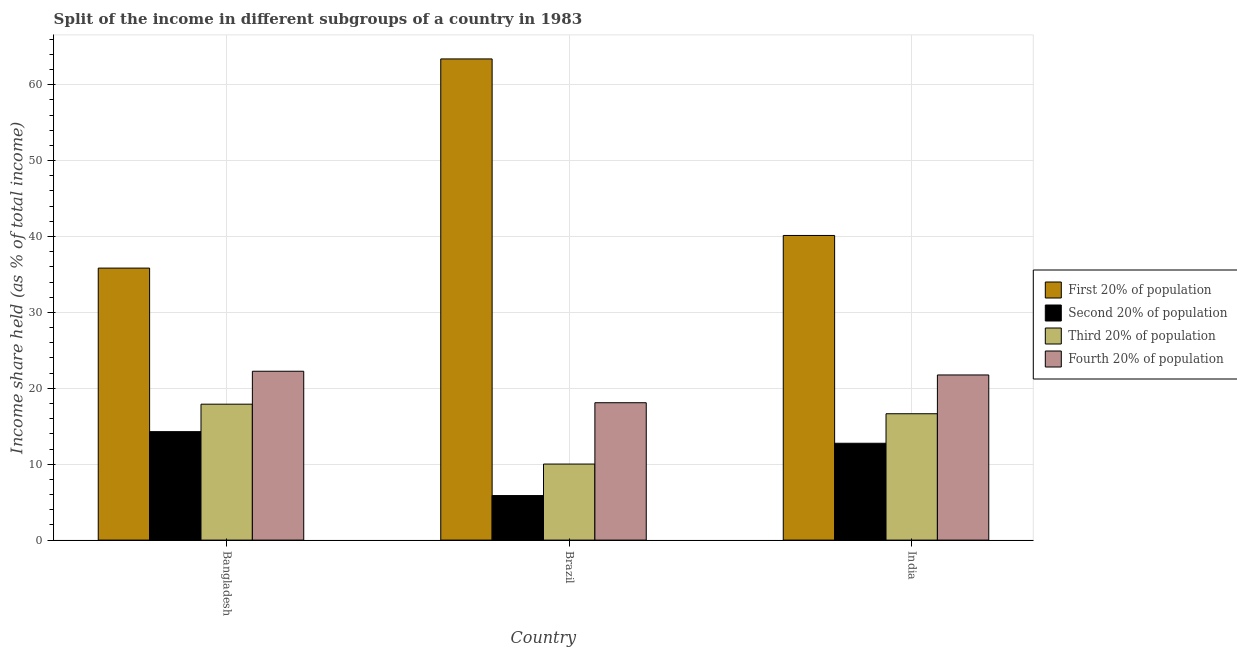How many groups of bars are there?
Make the answer very short. 3. What is the label of the 1st group of bars from the left?
Keep it short and to the point. Bangladesh. In how many cases, is the number of bars for a given country not equal to the number of legend labels?
Provide a short and direct response. 0. What is the share of the income held by first 20% of the population in India?
Offer a very short reply. 40.14. Across all countries, what is the maximum share of the income held by third 20% of the population?
Offer a very short reply. 17.91. Across all countries, what is the minimum share of the income held by second 20% of the population?
Your answer should be very brief. 5.87. In which country was the share of the income held by second 20% of the population maximum?
Your response must be concise. Bangladesh. What is the total share of the income held by first 20% of the population in the graph?
Provide a short and direct response. 139.38. What is the difference between the share of the income held by second 20% of the population in Bangladesh and that in Brazil?
Give a very brief answer. 8.42. What is the difference between the share of the income held by fourth 20% of the population in Brazil and the share of the income held by first 20% of the population in India?
Make the answer very short. -22.04. What is the average share of the income held by third 20% of the population per country?
Your answer should be very brief. 14.86. What is the difference between the share of the income held by third 20% of the population and share of the income held by fourth 20% of the population in Brazil?
Offer a terse response. -8.08. In how many countries, is the share of the income held by second 20% of the population greater than 40 %?
Make the answer very short. 0. What is the ratio of the share of the income held by second 20% of the population in Bangladesh to that in Brazil?
Ensure brevity in your answer.  2.43. What is the difference between the highest and the second highest share of the income held by first 20% of the population?
Provide a succinct answer. 23.26. What is the difference between the highest and the lowest share of the income held by first 20% of the population?
Provide a succinct answer. 27.56. In how many countries, is the share of the income held by third 20% of the population greater than the average share of the income held by third 20% of the population taken over all countries?
Give a very brief answer. 2. Is it the case that in every country, the sum of the share of the income held by fourth 20% of the population and share of the income held by first 20% of the population is greater than the sum of share of the income held by second 20% of the population and share of the income held by third 20% of the population?
Your answer should be compact. Yes. What does the 2nd bar from the left in Brazil represents?
Your answer should be compact. Second 20% of population. What does the 1st bar from the right in India represents?
Keep it short and to the point. Fourth 20% of population. Is it the case that in every country, the sum of the share of the income held by first 20% of the population and share of the income held by second 20% of the population is greater than the share of the income held by third 20% of the population?
Offer a terse response. Yes. How many countries are there in the graph?
Give a very brief answer. 3. What is the difference between two consecutive major ticks on the Y-axis?
Your response must be concise. 10. Does the graph contain grids?
Provide a short and direct response. Yes. How many legend labels are there?
Provide a short and direct response. 4. What is the title of the graph?
Provide a succinct answer. Split of the income in different subgroups of a country in 1983. Does "Argument" appear as one of the legend labels in the graph?
Offer a very short reply. No. What is the label or title of the Y-axis?
Make the answer very short. Income share held (as % of total income). What is the Income share held (as % of total income) in First 20% of population in Bangladesh?
Offer a very short reply. 35.84. What is the Income share held (as % of total income) in Second 20% of population in Bangladesh?
Give a very brief answer. 14.29. What is the Income share held (as % of total income) in Third 20% of population in Bangladesh?
Make the answer very short. 17.91. What is the Income share held (as % of total income) of Fourth 20% of population in Bangladesh?
Your answer should be compact. 22.25. What is the Income share held (as % of total income) of First 20% of population in Brazil?
Make the answer very short. 63.4. What is the Income share held (as % of total income) in Second 20% of population in Brazil?
Give a very brief answer. 5.87. What is the Income share held (as % of total income) of Third 20% of population in Brazil?
Keep it short and to the point. 10.02. What is the Income share held (as % of total income) of First 20% of population in India?
Your answer should be compact. 40.14. What is the Income share held (as % of total income) of Second 20% of population in India?
Give a very brief answer. 12.76. What is the Income share held (as % of total income) of Third 20% of population in India?
Your answer should be compact. 16.65. What is the Income share held (as % of total income) of Fourth 20% of population in India?
Provide a short and direct response. 21.76. Across all countries, what is the maximum Income share held (as % of total income) of First 20% of population?
Your answer should be very brief. 63.4. Across all countries, what is the maximum Income share held (as % of total income) in Second 20% of population?
Your answer should be very brief. 14.29. Across all countries, what is the maximum Income share held (as % of total income) in Third 20% of population?
Make the answer very short. 17.91. Across all countries, what is the maximum Income share held (as % of total income) of Fourth 20% of population?
Provide a succinct answer. 22.25. Across all countries, what is the minimum Income share held (as % of total income) in First 20% of population?
Ensure brevity in your answer.  35.84. Across all countries, what is the minimum Income share held (as % of total income) of Second 20% of population?
Offer a very short reply. 5.87. Across all countries, what is the minimum Income share held (as % of total income) of Third 20% of population?
Keep it short and to the point. 10.02. Across all countries, what is the minimum Income share held (as % of total income) in Fourth 20% of population?
Offer a very short reply. 18.1. What is the total Income share held (as % of total income) of First 20% of population in the graph?
Keep it short and to the point. 139.38. What is the total Income share held (as % of total income) of Second 20% of population in the graph?
Your response must be concise. 32.92. What is the total Income share held (as % of total income) in Third 20% of population in the graph?
Provide a short and direct response. 44.58. What is the total Income share held (as % of total income) of Fourth 20% of population in the graph?
Ensure brevity in your answer.  62.11. What is the difference between the Income share held (as % of total income) of First 20% of population in Bangladesh and that in Brazil?
Offer a terse response. -27.56. What is the difference between the Income share held (as % of total income) in Second 20% of population in Bangladesh and that in Brazil?
Offer a very short reply. 8.42. What is the difference between the Income share held (as % of total income) in Third 20% of population in Bangladesh and that in Brazil?
Your response must be concise. 7.89. What is the difference between the Income share held (as % of total income) of Fourth 20% of population in Bangladesh and that in Brazil?
Offer a very short reply. 4.15. What is the difference between the Income share held (as % of total income) in First 20% of population in Bangladesh and that in India?
Your answer should be compact. -4.3. What is the difference between the Income share held (as % of total income) in Second 20% of population in Bangladesh and that in India?
Keep it short and to the point. 1.53. What is the difference between the Income share held (as % of total income) of Third 20% of population in Bangladesh and that in India?
Offer a very short reply. 1.26. What is the difference between the Income share held (as % of total income) of Fourth 20% of population in Bangladesh and that in India?
Provide a short and direct response. 0.49. What is the difference between the Income share held (as % of total income) in First 20% of population in Brazil and that in India?
Ensure brevity in your answer.  23.26. What is the difference between the Income share held (as % of total income) of Second 20% of population in Brazil and that in India?
Offer a terse response. -6.89. What is the difference between the Income share held (as % of total income) in Third 20% of population in Brazil and that in India?
Offer a terse response. -6.63. What is the difference between the Income share held (as % of total income) in Fourth 20% of population in Brazil and that in India?
Keep it short and to the point. -3.66. What is the difference between the Income share held (as % of total income) of First 20% of population in Bangladesh and the Income share held (as % of total income) of Second 20% of population in Brazil?
Your response must be concise. 29.97. What is the difference between the Income share held (as % of total income) of First 20% of population in Bangladesh and the Income share held (as % of total income) of Third 20% of population in Brazil?
Give a very brief answer. 25.82. What is the difference between the Income share held (as % of total income) in First 20% of population in Bangladesh and the Income share held (as % of total income) in Fourth 20% of population in Brazil?
Your response must be concise. 17.74. What is the difference between the Income share held (as % of total income) in Second 20% of population in Bangladesh and the Income share held (as % of total income) in Third 20% of population in Brazil?
Offer a very short reply. 4.27. What is the difference between the Income share held (as % of total income) of Second 20% of population in Bangladesh and the Income share held (as % of total income) of Fourth 20% of population in Brazil?
Provide a short and direct response. -3.81. What is the difference between the Income share held (as % of total income) of Third 20% of population in Bangladesh and the Income share held (as % of total income) of Fourth 20% of population in Brazil?
Keep it short and to the point. -0.19. What is the difference between the Income share held (as % of total income) of First 20% of population in Bangladesh and the Income share held (as % of total income) of Second 20% of population in India?
Your response must be concise. 23.08. What is the difference between the Income share held (as % of total income) in First 20% of population in Bangladesh and the Income share held (as % of total income) in Third 20% of population in India?
Provide a succinct answer. 19.19. What is the difference between the Income share held (as % of total income) of First 20% of population in Bangladesh and the Income share held (as % of total income) of Fourth 20% of population in India?
Make the answer very short. 14.08. What is the difference between the Income share held (as % of total income) in Second 20% of population in Bangladesh and the Income share held (as % of total income) in Third 20% of population in India?
Your answer should be compact. -2.36. What is the difference between the Income share held (as % of total income) of Second 20% of population in Bangladesh and the Income share held (as % of total income) of Fourth 20% of population in India?
Offer a terse response. -7.47. What is the difference between the Income share held (as % of total income) of Third 20% of population in Bangladesh and the Income share held (as % of total income) of Fourth 20% of population in India?
Your answer should be very brief. -3.85. What is the difference between the Income share held (as % of total income) of First 20% of population in Brazil and the Income share held (as % of total income) of Second 20% of population in India?
Your response must be concise. 50.64. What is the difference between the Income share held (as % of total income) of First 20% of population in Brazil and the Income share held (as % of total income) of Third 20% of population in India?
Your answer should be very brief. 46.75. What is the difference between the Income share held (as % of total income) in First 20% of population in Brazil and the Income share held (as % of total income) in Fourth 20% of population in India?
Give a very brief answer. 41.64. What is the difference between the Income share held (as % of total income) of Second 20% of population in Brazil and the Income share held (as % of total income) of Third 20% of population in India?
Make the answer very short. -10.78. What is the difference between the Income share held (as % of total income) in Second 20% of population in Brazil and the Income share held (as % of total income) in Fourth 20% of population in India?
Your response must be concise. -15.89. What is the difference between the Income share held (as % of total income) of Third 20% of population in Brazil and the Income share held (as % of total income) of Fourth 20% of population in India?
Provide a succinct answer. -11.74. What is the average Income share held (as % of total income) in First 20% of population per country?
Make the answer very short. 46.46. What is the average Income share held (as % of total income) of Second 20% of population per country?
Provide a short and direct response. 10.97. What is the average Income share held (as % of total income) in Third 20% of population per country?
Offer a terse response. 14.86. What is the average Income share held (as % of total income) of Fourth 20% of population per country?
Your answer should be very brief. 20.7. What is the difference between the Income share held (as % of total income) of First 20% of population and Income share held (as % of total income) of Second 20% of population in Bangladesh?
Make the answer very short. 21.55. What is the difference between the Income share held (as % of total income) in First 20% of population and Income share held (as % of total income) in Third 20% of population in Bangladesh?
Offer a very short reply. 17.93. What is the difference between the Income share held (as % of total income) in First 20% of population and Income share held (as % of total income) in Fourth 20% of population in Bangladesh?
Provide a succinct answer. 13.59. What is the difference between the Income share held (as % of total income) in Second 20% of population and Income share held (as % of total income) in Third 20% of population in Bangladesh?
Provide a succinct answer. -3.62. What is the difference between the Income share held (as % of total income) in Second 20% of population and Income share held (as % of total income) in Fourth 20% of population in Bangladesh?
Your response must be concise. -7.96. What is the difference between the Income share held (as % of total income) in Third 20% of population and Income share held (as % of total income) in Fourth 20% of population in Bangladesh?
Make the answer very short. -4.34. What is the difference between the Income share held (as % of total income) of First 20% of population and Income share held (as % of total income) of Second 20% of population in Brazil?
Your answer should be very brief. 57.53. What is the difference between the Income share held (as % of total income) of First 20% of population and Income share held (as % of total income) of Third 20% of population in Brazil?
Provide a short and direct response. 53.38. What is the difference between the Income share held (as % of total income) of First 20% of population and Income share held (as % of total income) of Fourth 20% of population in Brazil?
Give a very brief answer. 45.3. What is the difference between the Income share held (as % of total income) of Second 20% of population and Income share held (as % of total income) of Third 20% of population in Brazil?
Your response must be concise. -4.15. What is the difference between the Income share held (as % of total income) of Second 20% of population and Income share held (as % of total income) of Fourth 20% of population in Brazil?
Provide a succinct answer. -12.23. What is the difference between the Income share held (as % of total income) of Third 20% of population and Income share held (as % of total income) of Fourth 20% of population in Brazil?
Provide a succinct answer. -8.08. What is the difference between the Income share held (as % of total income) of First 20% of population and Income share held (as % of total income) of Second 20% of population in India?
Ensure brevity in your answer.  27.38. What is the difference between the Income share held (as % of total income) of First 20% of population and Income share held (as % of total income) of Third 20% of population in India?
Offer a terse response. 23.49. What is the difference between the Income share held (as % of total income) of First 20% of population and Income share held (as % of total income) of Fourth 20% of population in India?
Ensure brevity in your answer.  18.38. What is the difference between the Income share held (as % of total income) in Second 20% of population and Income share held (as % of total income) in Third 20% of population in India?
Provide a short and direct response. -3.89. What is the difference between the Income share held (as % of total income) in Third 20% of population and Income share held (as % of total income) in Fourth 20% of population in India?
Offer a terse response. -5.11. What is the ratio of the Income share held (as % of total income) of First 20% of population in Bangladesh to that in Brazil?
Your answer should be very brief. 0.57. What is the ratio of the Income share held (as % of total income) in Second 20% of population in Bangladesh to that in Brazil?
Ensure brevity in your answer.  2.43. What is the ratio of the Income share held (as % of total income) in Third 20% of population in Bangladesh to that in Brazil?
Your answer should be compact. 1.79. What is the ratio of the Income share held (as % of total income) in Fourth 20% of population in Bangladesh to that in Brazil?
Offer a terse response. 1.23. What is the ratio of the Income share held (as % of total income) of First 20% of population in Bangladesh to that in India?
Provide a short and direct response. 0.89. What is the ratio of the Income share held (as % of total income) in Second 20% of population in Bangladesh to that in India?
Make the answer very short. 1.12. What is the ratio of the Income share held (as % of total income) of Third 20% of population in Bangladesh to that in India?
Offer a very short reply. 1.08. What is the ratio of the Income share held (as % of total income) of Fourth 20% of population in Bangladesh to that in India?
Keep it short and to the point. 1.02. What is the ratio of the Income share held (as % of total income) in First 20% of population in Brazil to that in India?
Give a very brief answer. 1.58. What is the ratio of the Income share held (as % of total income) of Second 20% of population in Brazil to that in India?
Your response must be concise. 0.46. What is the ratio of the Income share held (as % of total income) of Third 20% of population in Brazil to that in India?
Your answer should be compact. 0.6. What is the ratio of the Income share held (as % of total income) of Fourth 20% of population in Brazil to that in India?
Keep it short and to the point. 0.83. What is the difference between the highest and the second highest Income share held (as % of total income) in First 20% of population?
Offer a terse response. 23.26. What is the difference between the highest and the second highest Income share held (as % of total income) of Second 20% of population?
Keep it short and to the point. 1.53. What is the difference between the highest and the second highest Income share held (as % of total income) in Third 20% of population?
Provide a short and direct response. 1.26. What is the difference between the highest and the second highest Income share held (as % of total income) of Fourth 20% of population?
Offer a terse response. 0.49. What is the difference between the highest and the lowest Income share held (as % of total income) in First 20% of population?
Offer a terse response. 27.56. What is the difference between the highest and the lowest Income share held (as % of total income) of Second 20% of population?
Your answer should be very brief. 8.42. What is the difference between the highest and the lowest Income share held (as % of total income) of Third 20% of population?
Provide a short and direct response. 7.89. What is the difference between the highest and the lowest Income share held (as % of total income) in Fourth 20% of population?
Ensure brevity in your answer.  4.15. 